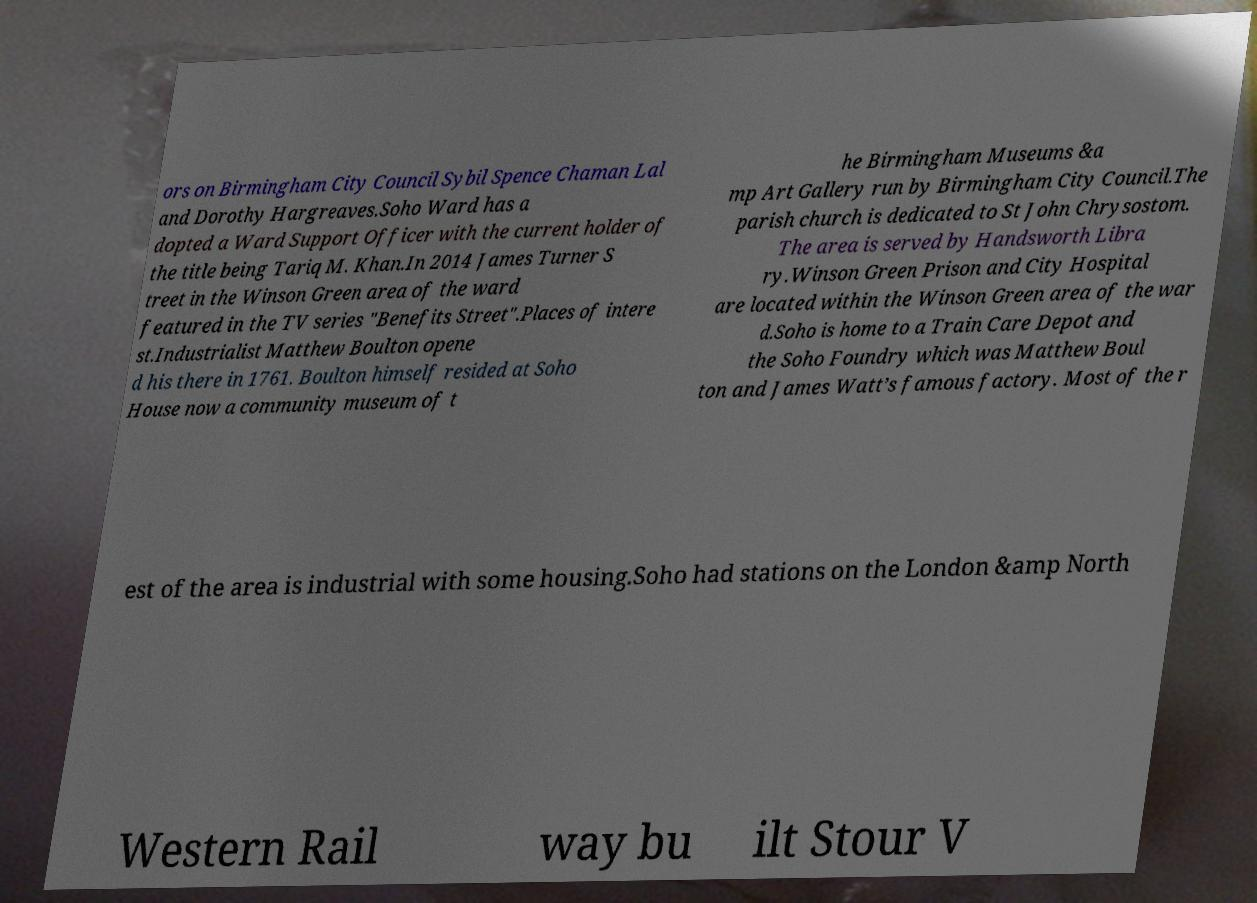Can you accurately transcribe the text from the provided image for me? ors on Birmingham City Council Sybil Spence Chaman Lal and Dorothy Hargreaves.Soho Ward has a dopted a Ward Support Officer with the current holder of the title being Tariq M. Khan.In 2014 James Turner S treet in the Winson Green area of the ward featured in the TV series "Benefits Street".Places of intere st.Industrialist Matthew Boulton opene d his there in 1761. Boulton himself resided at Soho House now a community museum of t he Birmingham Museums &a mp Art Gallery run by Birmingham City Council.The parish church is dedicated to St John Chrysostom. The area is served by Handsworth Libra ry.Winson Green Prison and City Hospital are located within the Winson Green area of the war d.Soho is home to a Train Care Depot and the Soho Foundry which was Matthew Boul ton and James Watt’s famous factory. Most of the r est of the area is industrial with some housing.Soho had stations on the London &amp North Western Rail way bu ilt Stour V 